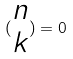<formula> <loc_0><loc_0><loc_500><loc_500>( \begin{matrix} n \\ k \end{matrix} ) = 0</formula> 